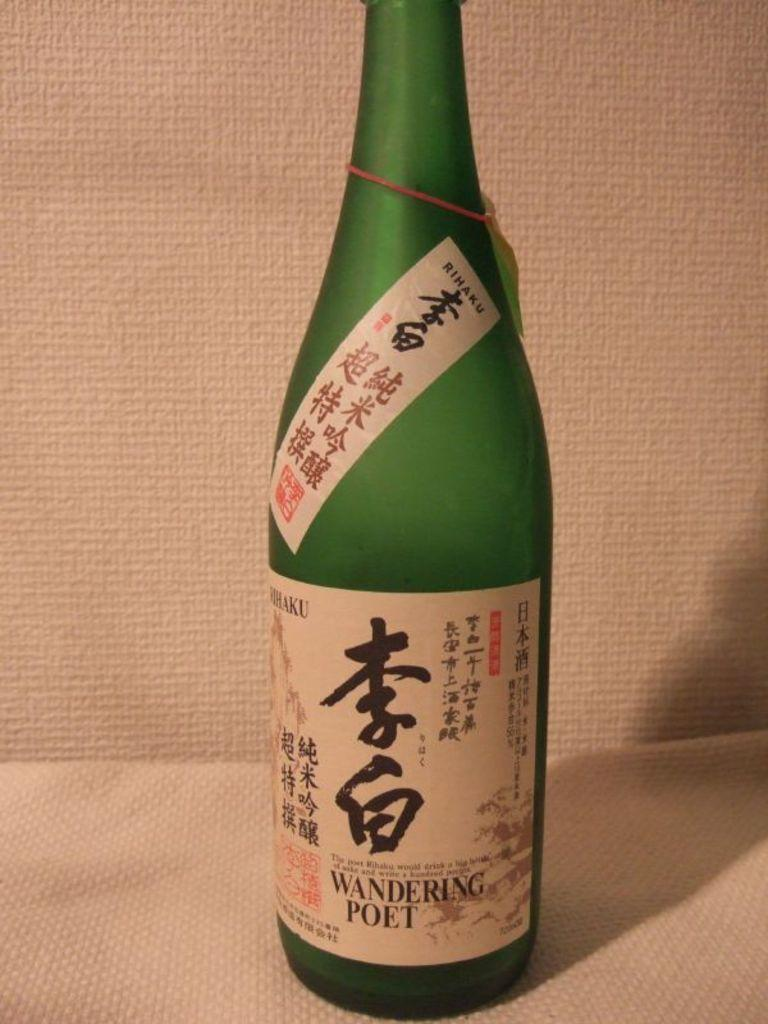Provide a one-sentence caption for the provided image. A large green bottle of Wandering poet liquor. 